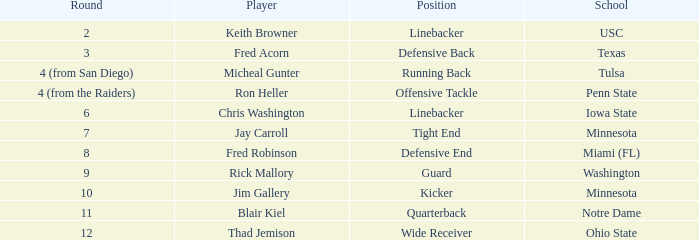What is the total number of picks made in the second round? 1.0. 